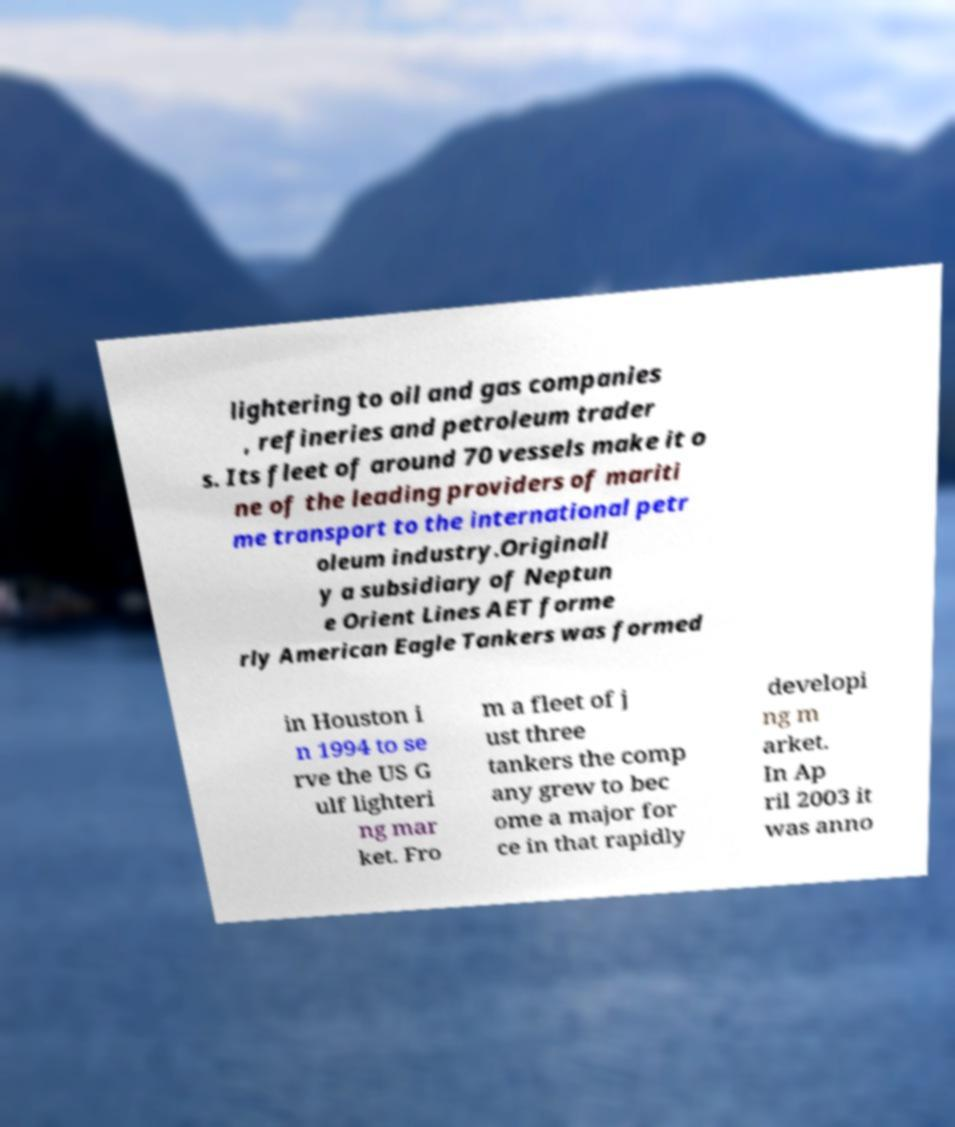There's text embedded in this image that I need extracted. Can you transcribe it verbatim? lightering to oil and gas companies , refineries and petroleum trader s. Its fleet of around 70 vessels make it o ne of the leading providers of mariti me transport to the international petr oleum industry.Originall y a subsidiary of Neptun e Orient Lines AET forme rly American Eagle Tankers was formed in Houston i n 1994 to se rve the US G ulf lighteri ng mar ket. Fro m a fleet of j ust three tankers the comp any grew to bec ome a major for ce in that rapidly developi ng m arket. In Ap ril 2003 it was anno 